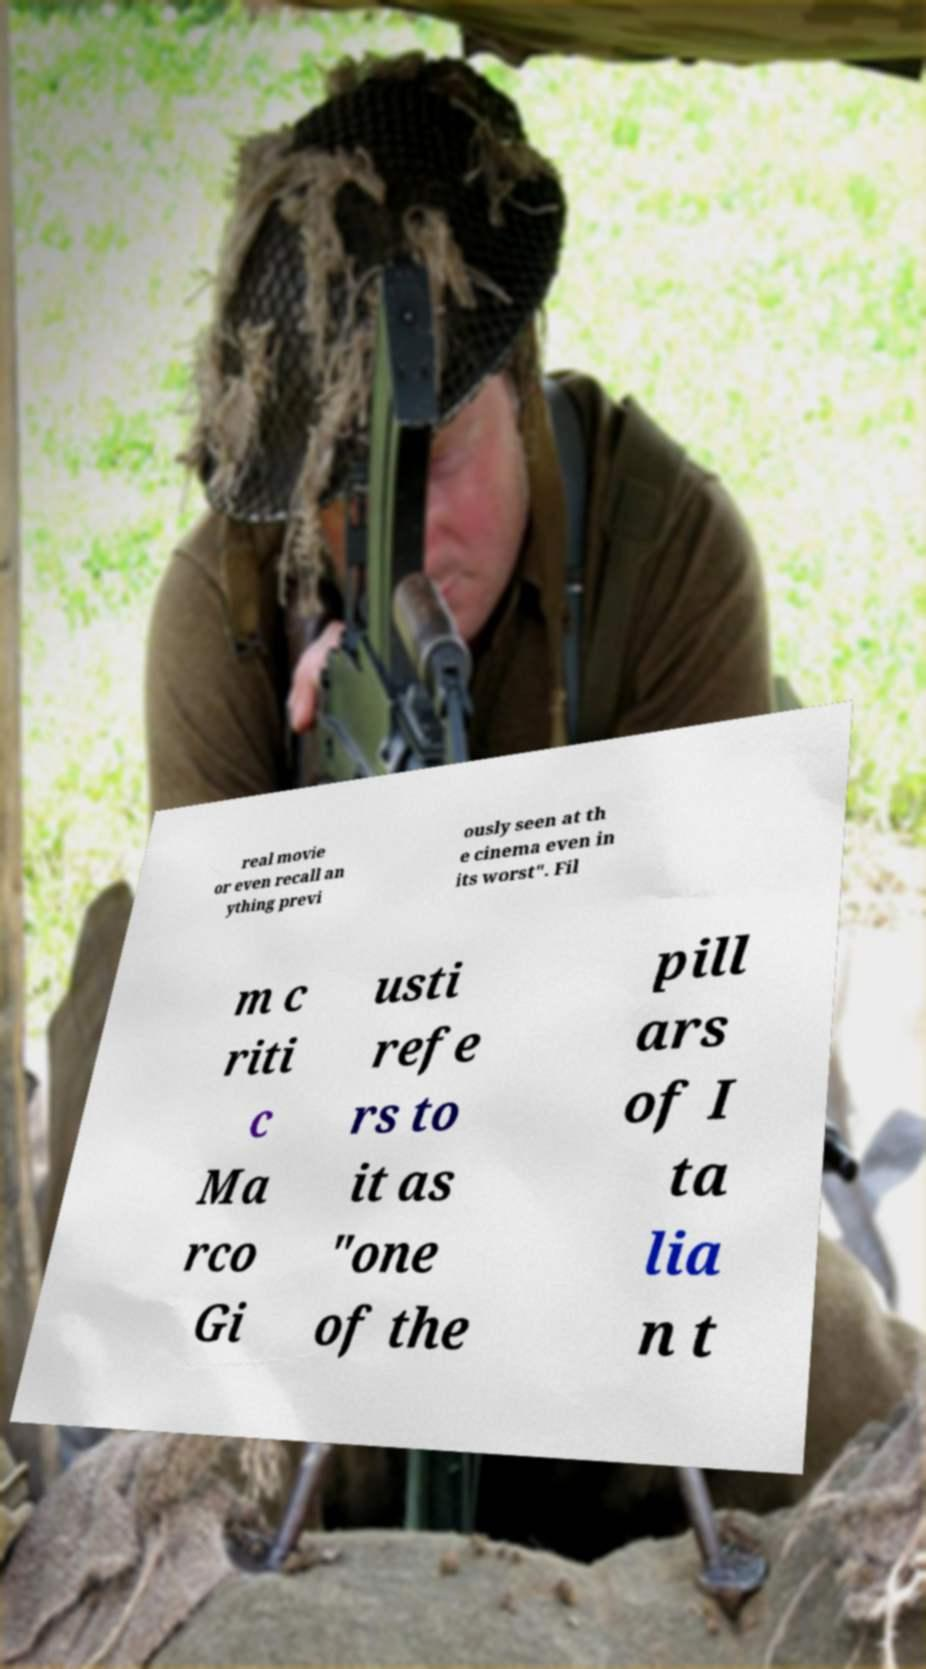What messages or text are displayed in this image? I need them in a readable, typed format. real movie or even recall an ything previ ously seen at th e cinema even in its worst". Fil m c riti c Ma rco Gi usti refe rs to it as "one of the pill ars of I ta lia n t 